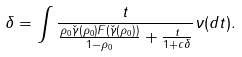<formula> <loc_0><loc_0><loc_500><loc_500>\delta & = \int \frac { t } { \frac { \rho _ { 0 } { \check { \gamma } ( \rho _ { 0 } ) } F ( { \check { \gamma } } ( \rho _ { 0 } ) ) } { 1 - \rho _ { 0 } } + \frac { t } { 1 + c \delta } } \nu ( d t ) .</formula> 